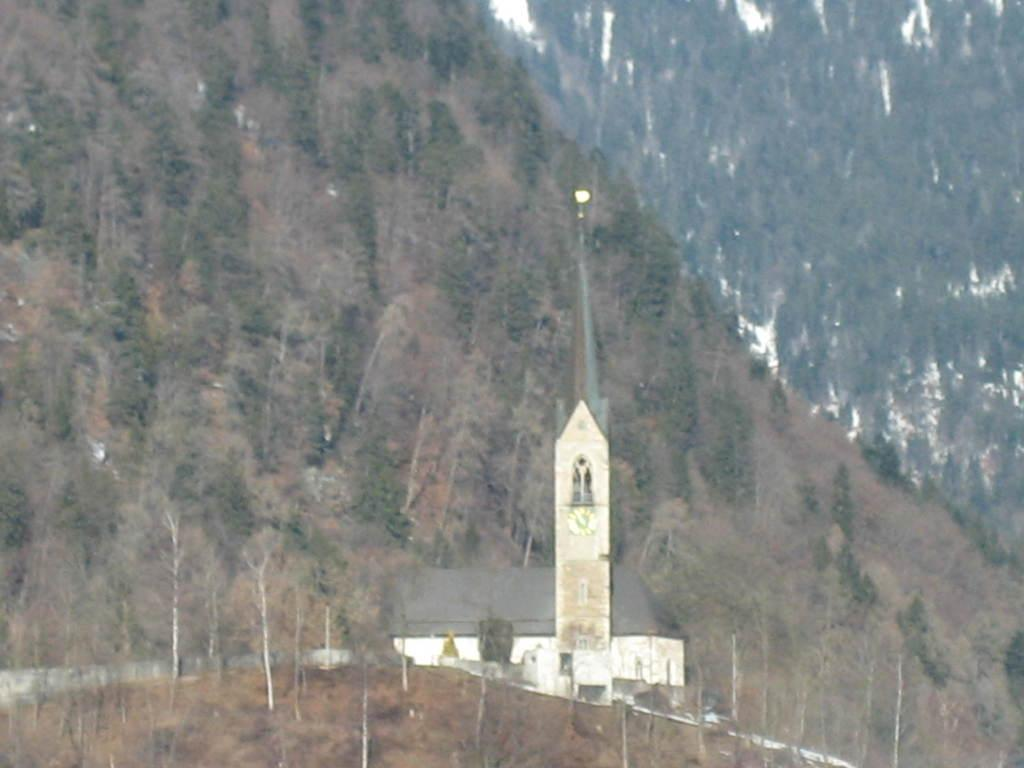What type of structure is visible in the image? There is a house in the image. What other objects can be seen in the image? There is a pole, a light, a wall, trees, and a mountain in the image. How does the table twist in the image? There is no table present in the image, so the question cannot be answered. 